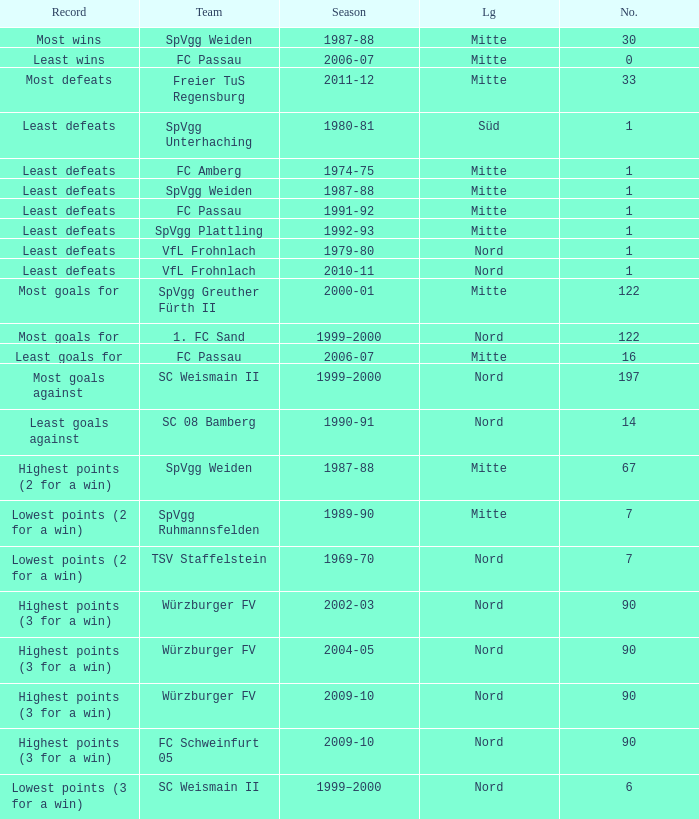What league has most wins as the record? Mitte. 